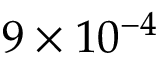Convert formula to latex. <formula><loc_0><loc_0><loc_500><loc_500>9 \times 1 0 ^ { - 4 }</formula> 